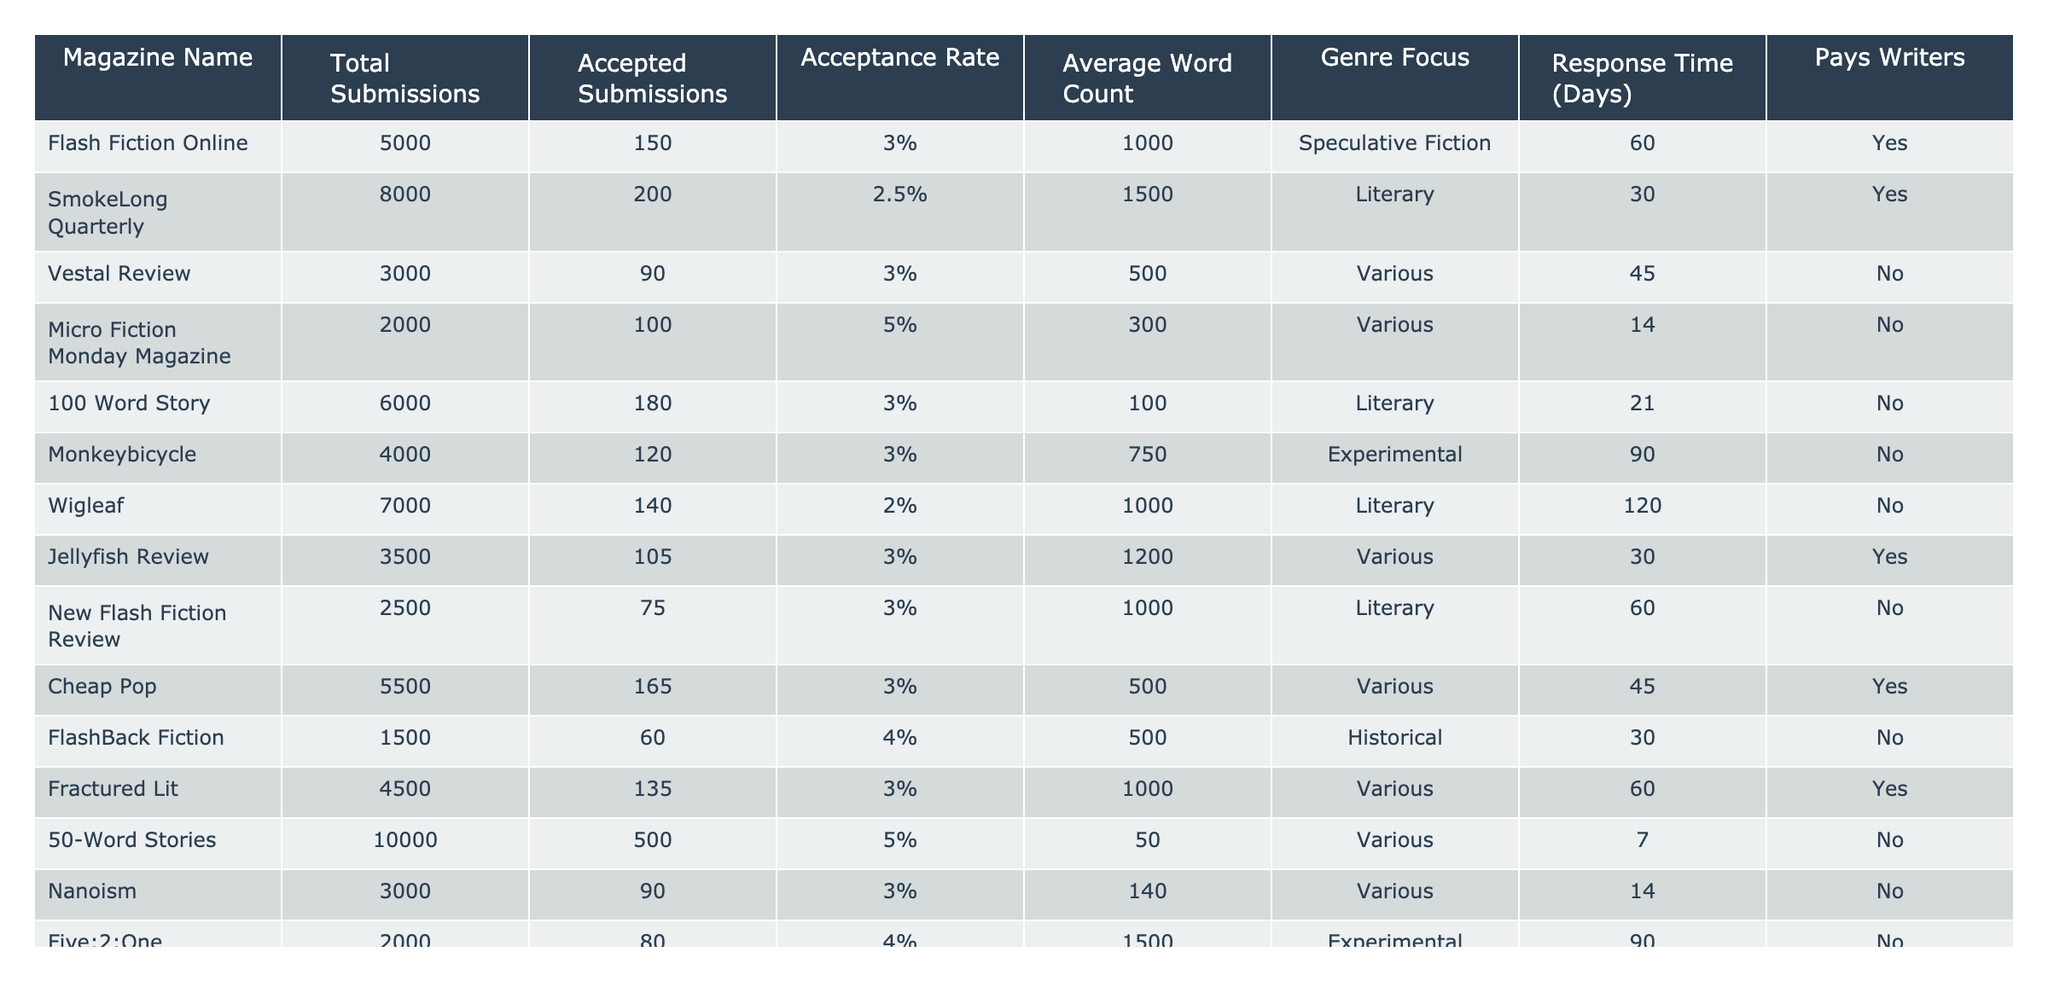What's the acceptance rate for Micro Fiction Monday Magazine? Looking at the table, we find that Micro Fiction Monday Magazine has an acceptance rate of 5%.
Answer: 5% Which magazine has the highest number of total submissions? The table shows that 50-Word Stories has the highest number of total submissions with 10,000.
Answer: 50-Word Stories How many magazines pay writers? By checking the "Pays Writers" column, we see that there are 5 magazines that pay writers.
Answer: 5 What is the average word count for submissions accepted by Flash Fiction Online? The table indicates that the average word count for Flash Fiction Online is 1,000 words.
Answer: 1,000 What’s the difference in acceptance rates between 50-Word Stories and SmokeLong Quarterly? The acceptance rate for 50-Word Stories is 5%, while for SmokeLong Quarterly it's 2.5%. The difference is 5% - 2.5% = 2.5%.
Answer: 2.5% Are there more magazines that focus on Literary or Experimental genres? Checking the genre focus, we find that there are 4 Literary-focused magazines and 3 Experimental-focused magazines. Since 4 is greater than 3, there are more Literary magazines.
Answer: Literary What is the average acceptance rate of all magazines listed? Calculating the average acceptance rate involves adding all acceptance rates (3% + 2.5% + 3% + 5% + 3% + 3% + 2% + 3% + 3% + 4% + 3% + 5% + 3% + 4%) and dividing by the number of magazines (14), which results in approximately 3.36%.
Answer: 3.36% Which magazine has the shortest response time? The "Response Time" column shows that Micro Fiction Monday Magazine has the shortest response time of 14 days.
Answer: 14 days If a writer submits to all magazines, what is the total number of submissions they will face? To find this, we add the total submissions of all magazines: 5000 + 8000 + 3000 + 2000 + 6000 + 4000 + 7000 + 3500 + 2500 + 5500 + 1500 + 4500 + 10000 + 3000 + 2000 =  56900 submissions.
Answer: 56,900 Which magazine has the lowest acceptance rate, and what is it? The table shows that Wigleaf has the lowest acceptance rate at 2%.
Answer: Wigleaf, 2% 